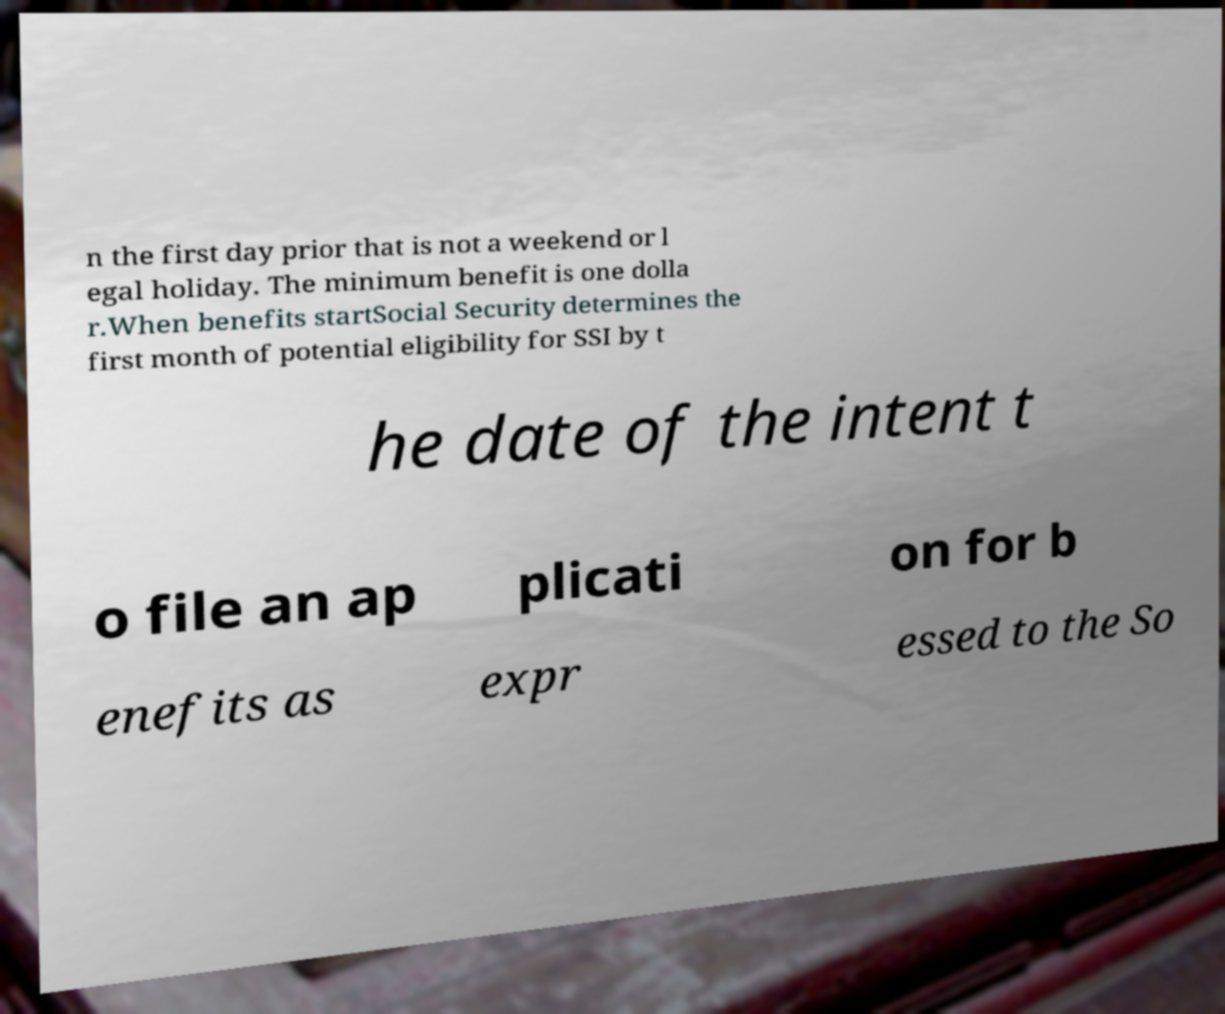There's text embedded in this image that I need extracted. Can you transcribe it verbatim? n the first day prior that is not a weekend or l egal holiday. The minimum benefit is one dolla r.When benefits startSocial Security determines the first month of potential eligibility for SSI by t he date of the intent t o file an ap plicati on for b enefits as expr essed to the So 